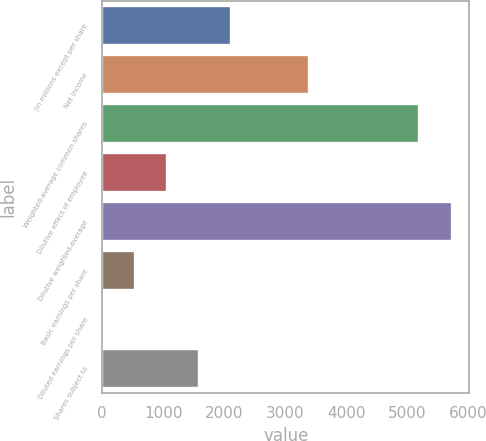<chart> <loc_0><loc_0><loc_500><loc_500><bar_chart><fcel>(in millions except per share<fcel>Net income<fcel>Weighted-average common shares<fcel>Dilutive effect of employee<fcel>Dilutive weighted-average<fcel>Basic earnings per share<fcel>Diluted earnings per share<fcel>Shares subject to<nl><fcel>2115.2<fcel>3381<fcel>5196<fcel>1057.92<fcel>5724.64<fcel>529.28<fcel>0.64<fcel>1586.56<nl></chart> 